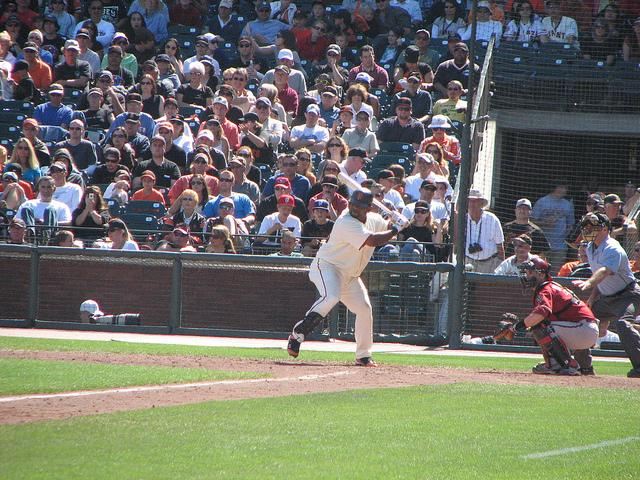What is different about this batter from most batters? left handed 